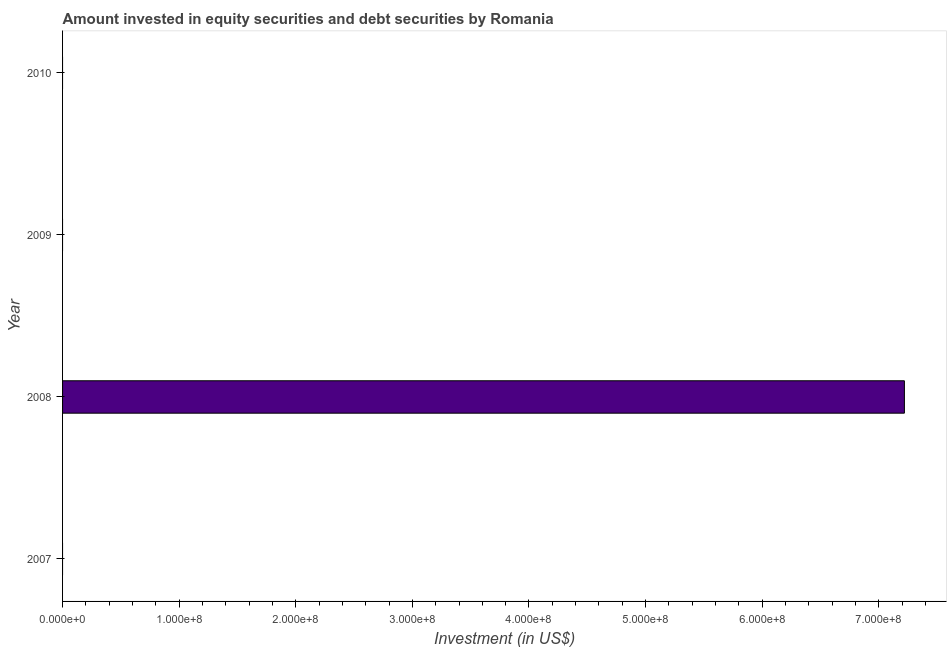Does the graph contain grids?
Keep it short and to the point. No. What is the title of the graph?
Make the answer very short. Amount invested in equity securities and debt securities by Romania. What is the label or title of the X-axis?
Make the answer very short. Investment (in US$). What is the portfolio investment in 2008?
Ensure brevity in your answer.  7.22e+08. Across all years, what is the maximum portfolio investment?
Keep it short and to the point. 7.22e+08. Across all years, what is the minimum portfolio investment?
Your response must be concise. 0. In which year was the portfolio investment maximum?
Your response must be concise. 2008. What is the sum of the portfolio investment?
Offer a very short reply. 7.22e+08. What is the average portfolio investment per year?
Your answer should be very brief. 1.80e+08. What is the median portfolio investment?
Your answer should be very brief. 0. What is the difference between the highest and the lowest portfolio investment?
Provide a succinct answer. 7.22e+08. Are the values on the major ticks of X-axis written in scientific E-notation?
Your answer should be very brief. Yes. What is the Investment (in US$) in 2007?
Offer a very short reply. 0. What is the Investment (in US$) in 2008?
Your answer should be compact. 7.22e+08. What is the Investment (in US$) of 2009?
Your response must be concise. 0. 